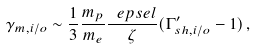<formula> <loc_0><loc_0><loc_500><loc_500>\gamma _ { m , i / o } \sim \frac { 1 } { 3 } \frac { m _ { p } } { m _ { e } } \frac { \ e p s e l } { \zeta } ( \Gamma ^ { \prime } _ { s h , i / o } - 1 ) \, ,</formula> 